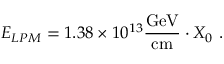Convert formula to latex. <formula><loc_0><loc_0><loc_500><loc_500>E _ { L P M } = 1 . 3 8 \times 1 0 ^ { 1 3 } \frac { G e V } { c m } \cdot X _ { 0 } \ .</formula> 